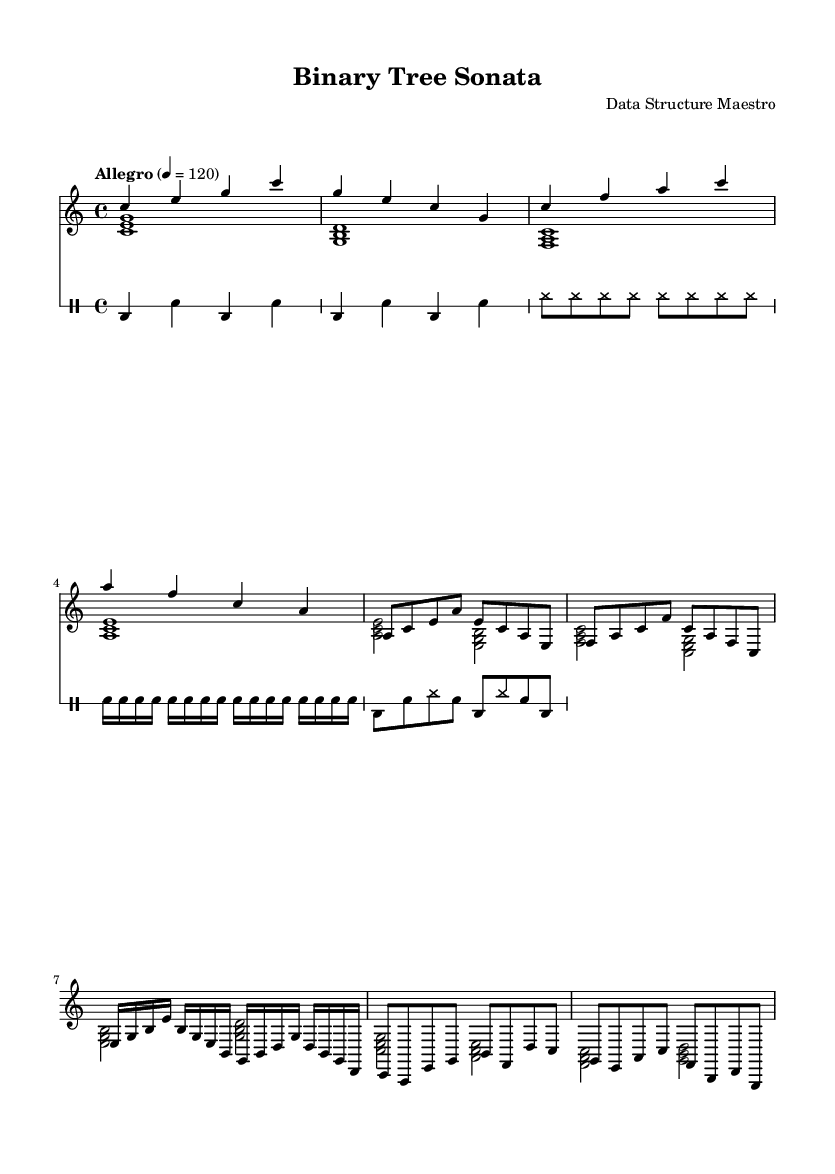What is the key signature of this music? The key signature is C major, which is indicated at the beginning of the piece with no sharps or flats.
Answer: C major What is the time signature of this music? The time signature is indicated as 4/4, meaning there are four beats in each measure.
Answer: 4/4 What is the tempo marking of this piece? The tempo marking indicates "Allegro," with a specific tempo setting of 120 beats per minute.
Answer: Allegro How many measures are in the right hand part? By counting the measures explicitly in the right hand music, there are a total of 8 measures noted.
Answer: 8 Which musical section is the root node represented in? The root node is represented in the opening measures of the right hand part, specifically in the first four measures.
Answer: Opening measures What type of percussion is used throughout the piece? The percussion section is entirely composed of bass drum and snare, with high hat sounds included in the left subtree section.
Answer: Bass drum and snare How does the left hand accompaniment relate to the right hand melody? The left hand provides harmonic support through chords that complement the melodic lines created in the right hand, maintaining a structural relationship throughout the piece.
Answer: Harmonic support 